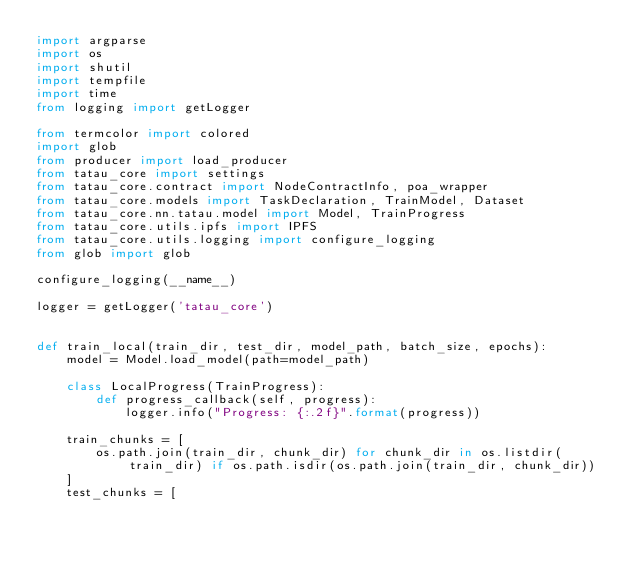<code> <loc_0><loc_0><loc_500><loc_500><_Python_>import argparse
import os
import shutil
import tempfile
import time
from logging import getLogger

from termcolor import colored
import glob
from producer import load_producer
from tatau_core import settings
from tatau_core.contract import NodeContractInfo, poa_wrapper
from tatau_core.models import TaskDeclaration, TrainModel, Dataset
from tatau_core.nn.tatau.model import Model, TrainProgress
from tatau_core.utils.ipfs import IPFS
from tatau_core.utils.logging import configure_logging
from glob import glob

configure_logging(__name__)

logger = getLogger('tatau_core')


def train_local(train_dir, test_dir, model_path, batch_size, epochs):
    model = Model.load_model(path=model_path)

    class LocalProgress(TrainProgress):
        def progress_callback(self, progress):
            logger.info("Progress: {:.2f}".format(progress))

    train_chunks = [
        os.path.join(train_dir, chunk_dir) for chunk_dir in os.listdir(train_dir) if os.path.isdir(os.path.join(train_dir, chunk_dir))
    ]
    test_chunks = [</code> 